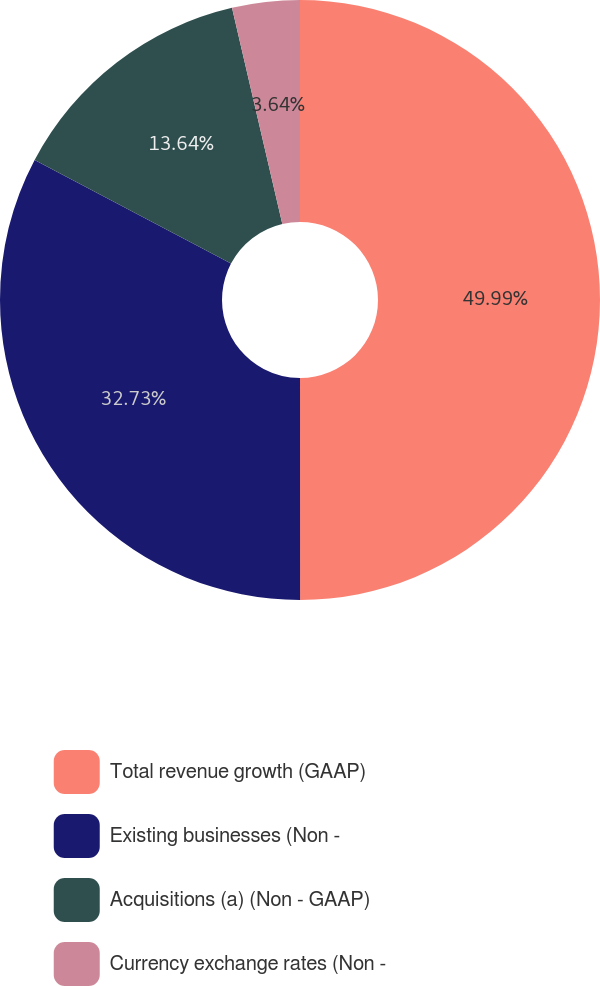Convert chart to OTSL. <chart><loc_0><loc_0><loc_500><loc_500><pie_chart><fcel>Total revenue growth (GAAP)<fcel>Existing businesses (Non -<fcel>Acquisitions (a) (Non - GAAP)<fcel>Currency exchange rates (Non -<nl><fcel>50.0%<fcel>32.73%<fcel>13.64%<fcel>3.64%<nl></chart> 